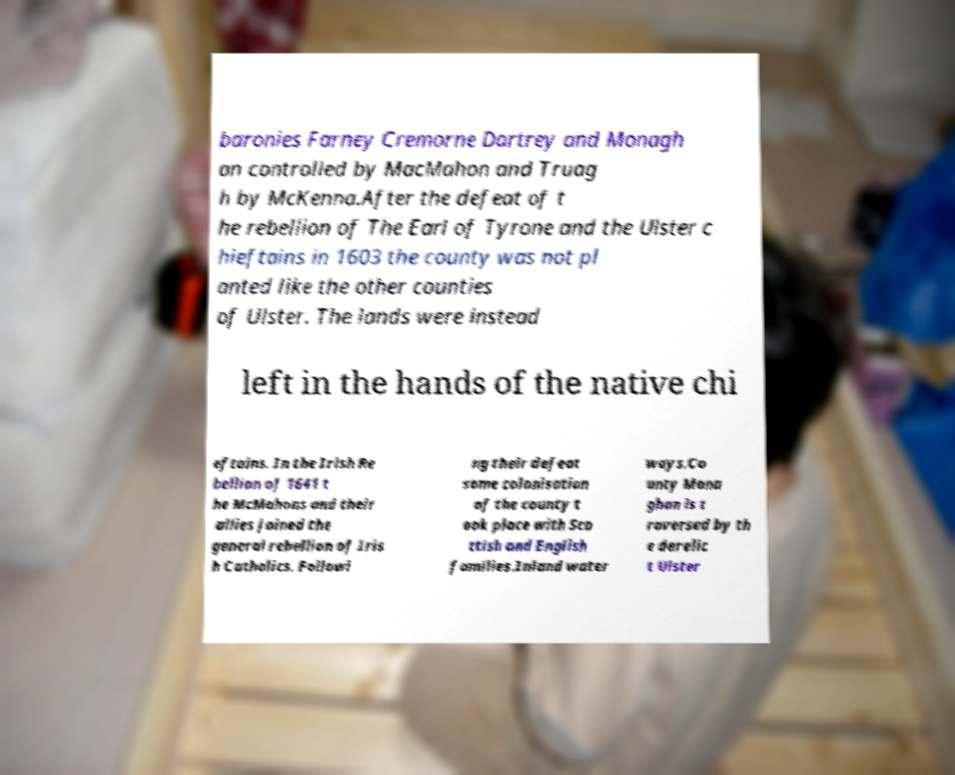There's text embedded in this image that I need extracted. Can you transcribe it verbatim? baronies Farney Cremorne Dartrey and Monagh an controlled by MacMahon and Truag h by McKenna.After the defeat of t he rebellion of The Earl of Tyrone and the Ulster c hieftains in 1603 the county was not pl anted like the other counties of Ulster. The lands were instead left in the hands of the native chi eftains. In the Irish Re bellion of 1641 t he McMahons and their allies joined the general rebellion of Iris h Catholics. Followi ng their defeat some colonisation of the county t ook place with Sco ttish and English families.Inland water ways.Co unty Mona ghan is t raversed by th e derelic t Ulster 